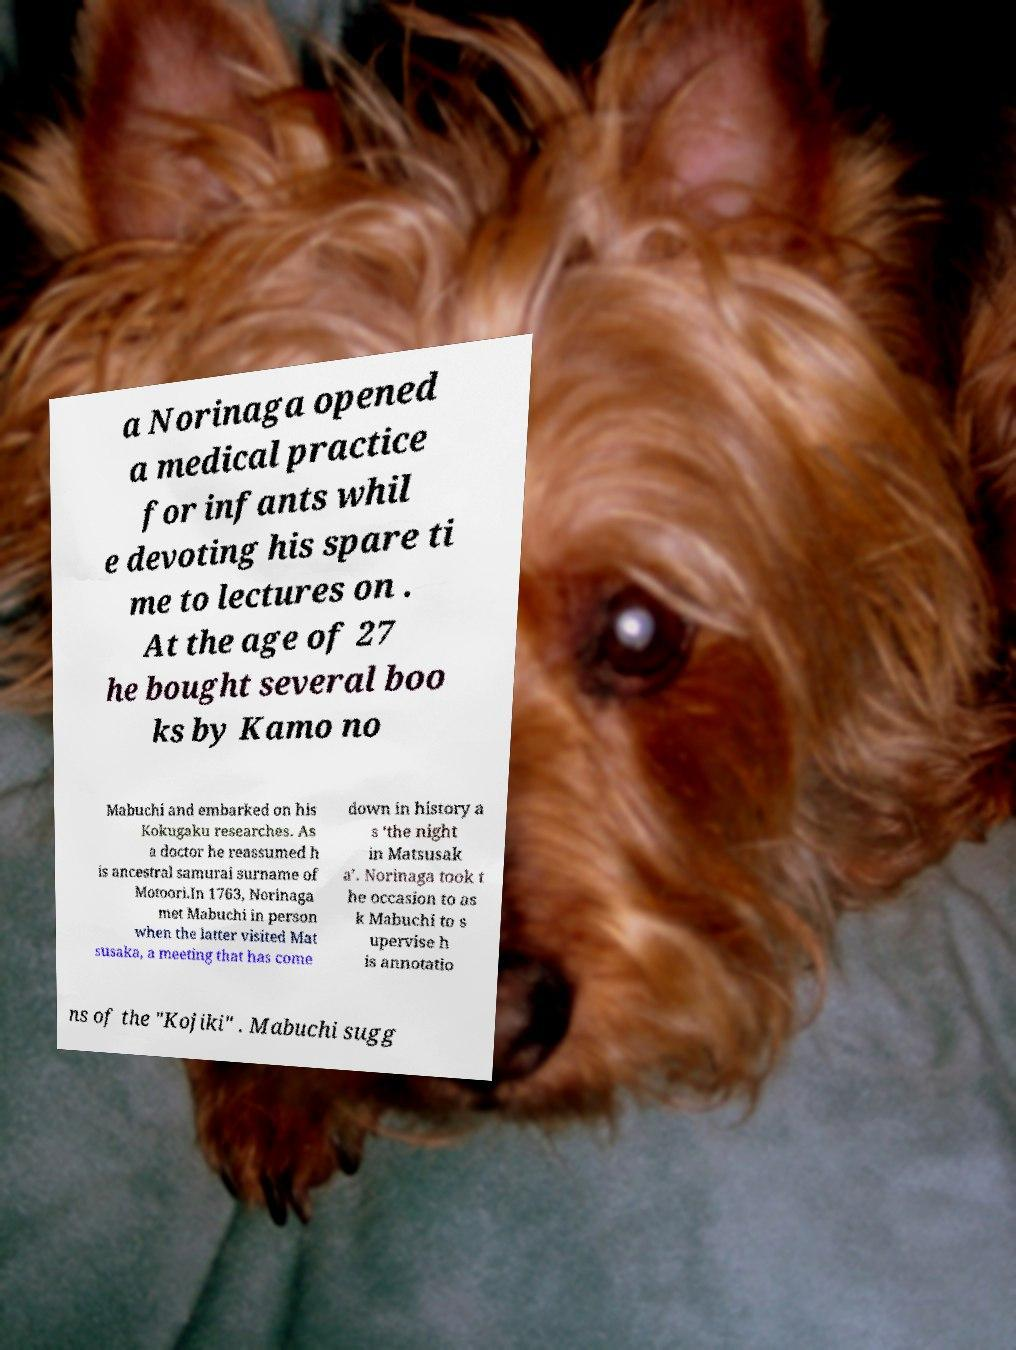What messages or text are displayed in this image? I need them in a readable, typed format. a Norinaga opened a medical practice for infants whil e devoting his spare ti me to lectures on . At the age of 27 he bought several boo ks by Kamo no Mabuchi and embarked on his Kokugaku researches. As a doctor he reassumed h is ancestral samurai surname of Motoori.In 1763, Norinaga met Mabuchi in person when the latter visited Mat susaka, a meeting that has come down in history a s ‘the night in Matsusak a’. Norinaga took t he occasion to as k Mabuchi to s upervise h is annotatio ns of the "Kojiki" . Mabuchi sugg 